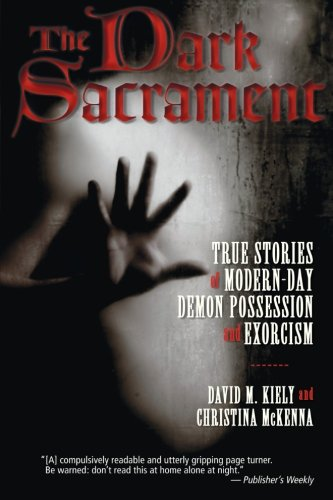What is the title of this book? The full title of the book is 'The Dark Sacrament: True Stories of Modern-Day Demon Possession and Exorcism'. 